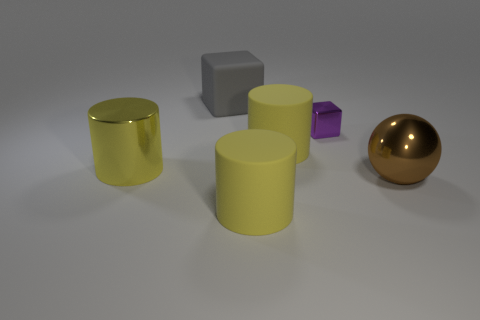Which object in this image appears to be the most reflective? The most reflective object in the image is the gold-colored sphere on the right. Its shiny surface reflects the light and the environment around it, unlike the other objects, which have less reflective, matte finishes. 